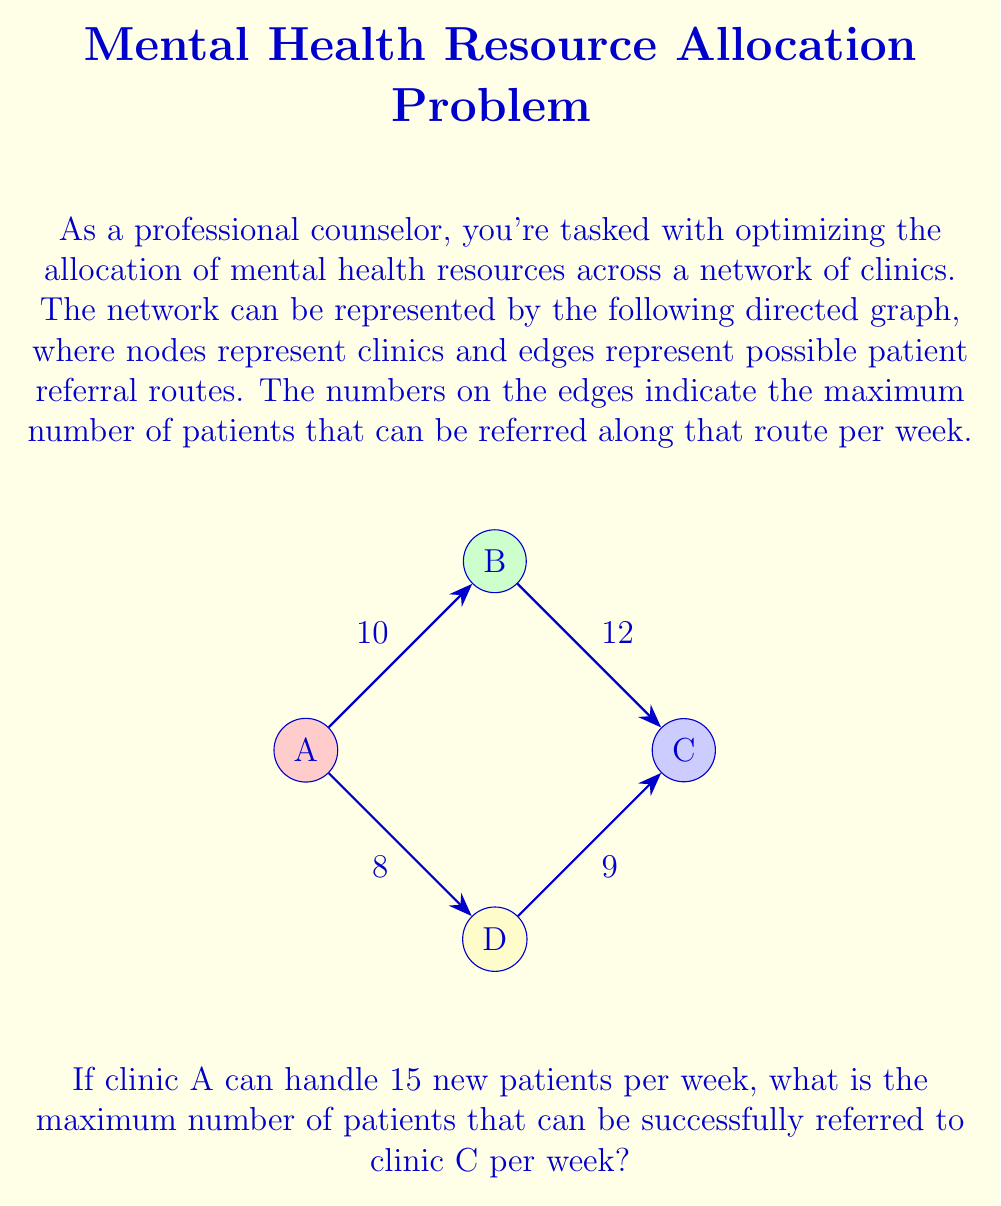Teach me how to tackle this problem. To solve this problem, we need to use the max-flow algorithm, which is a network flow algorithm used to find the maximum flow in a flow network. Here's a step-by-step approach:

1) First, identify the source (A) and sink (C) in our network.

2) The problem can be modeled as a max-flow problem where we want to find the maximum flow from A to C.

3) We can use the Ford-Fulkerson algorithm to solve this:

   a) Start with zero flow on all edges.
   
   b) Find an augmenting path from A to C. An augmenting path is a path with available capacity on all edges.
   
   c) Augment flow along this path by the minimum capacity on the path.
   
   d) Repeat steps b and c until no augmenting path exists.

4) Let's apply the algorithm:

   Path 1: A -> B -> C
   Minimum capacity: min(10, 12) = 10
   Flow after Path 1: 10

   Path 2: A -> D -> C
   Minimum capacity: min(8, 9) = 8
   Flow after Path 2: 10 + 8 = 18

5) No more augmenting paths exist, so the algorithm terminates.

6) The maximum flow is the sum of all flows: 18

7) However, we need to check if this exceeds the capacity of clinic A, which is 15 patients per week.

8) Since 18 > 15, the actual maximum flow is limited by clinic A's capacity of 15 patients per week.

Therefore, the maximum number of patients that can be successfully referred to clinic C per week is 15.
Answer: 15 patients per week 